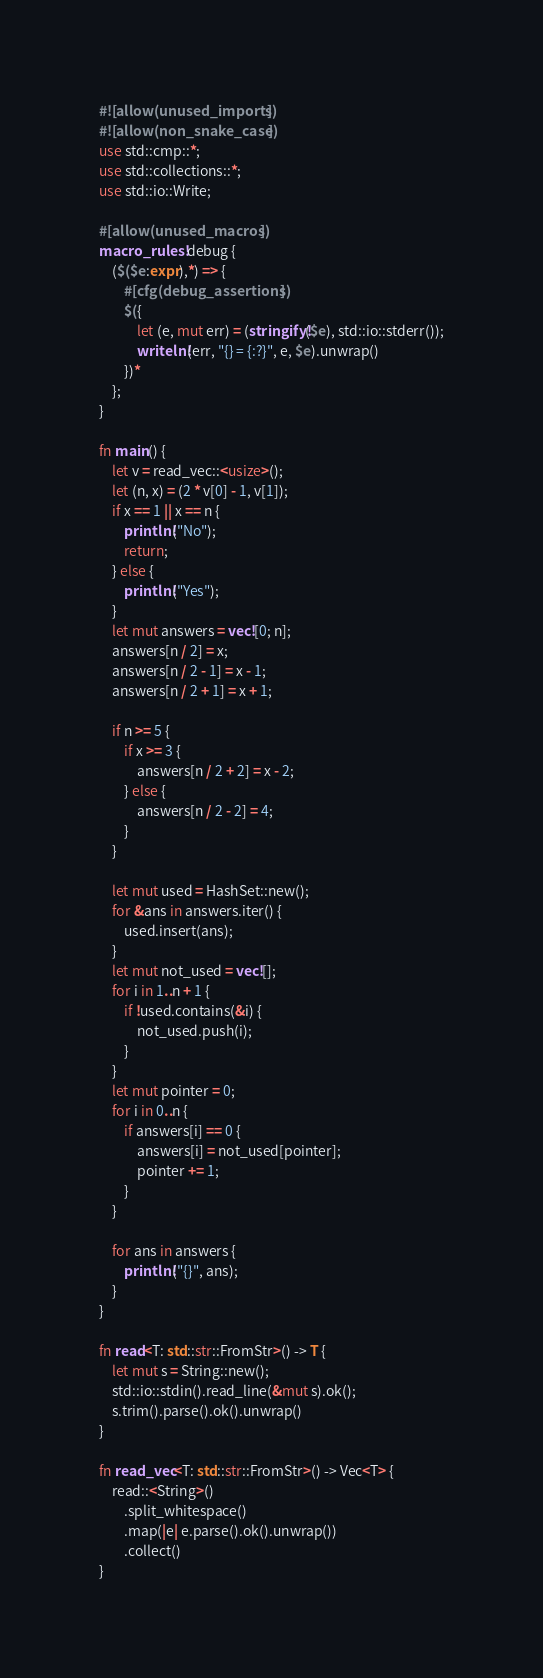Convert code to text. <code><loc_0><loc_0><loc_500><loc_500><_Rust_>#![allow(unused_imports)]
#![allow(non_snake_case)]
use std::cmp::*;
use std::collections::*;
use std::io::Write;

#[allow(unused_macros)]
macro_rules! debug {
    ($($e:expr),*) => {
        #[cfg(debug_assertions)]
        $({
            let (e, mut err) = (stringify!($e), std::io::stderr());
            writeln!(err, "{} = {:?}", e, $e).unwrap()
        })*
    };
}

fn main() {
    let v = read_vec::<usize>();
    let (n, x) = (2 * v[0] - 1, v[1]);
    if x == 1 || x == n {
        println!("No");
        return;
    } else {
        println!("Yes");
    }
    let mut answers = vec![0; n];
    answers[n / 2] = x;
    answers[n / 2 - 1] = x - 1;
    answers[n / 2 + 1] = x + 1;

    if n >= 5 {
        if x >= 3 {
            answers[n / 2 + 2] = x - 2;
        } else {
            answers[n / 2 - 2] = 4;
        }
    }

    let mut used = HashSet::new();
    for &ans in answers.iter() {
        used.insert(ans);
    }
    let mut not_used = vec![];
    for i in 1..n + 1 {
        if !used.contains(&i) {
            not_used.push(i);
        }
    }
    let mut pointer = 0;
    for i in 0..n {
        if answers[i] == 0 {
            answers[i] = not_used[pointer];
            pointer += 1;
        }
    }

    for ans in answers {
        println!("{}", ans);
    }
}

fn read<T: std::str::FromStr>() -> T {
    let mut s = String::new();
    std::io::stdin().read_line(&mut s).ok();
    s.trim().parse().ok().unwrap()
}

fn read_vec<T: std::str::FromStr>() -> Vec<T> {
    read::<String>()
        .split_whitespace()
        .map(|e| e.parse().ok().unwrap())
        .collect()
}
</code> 